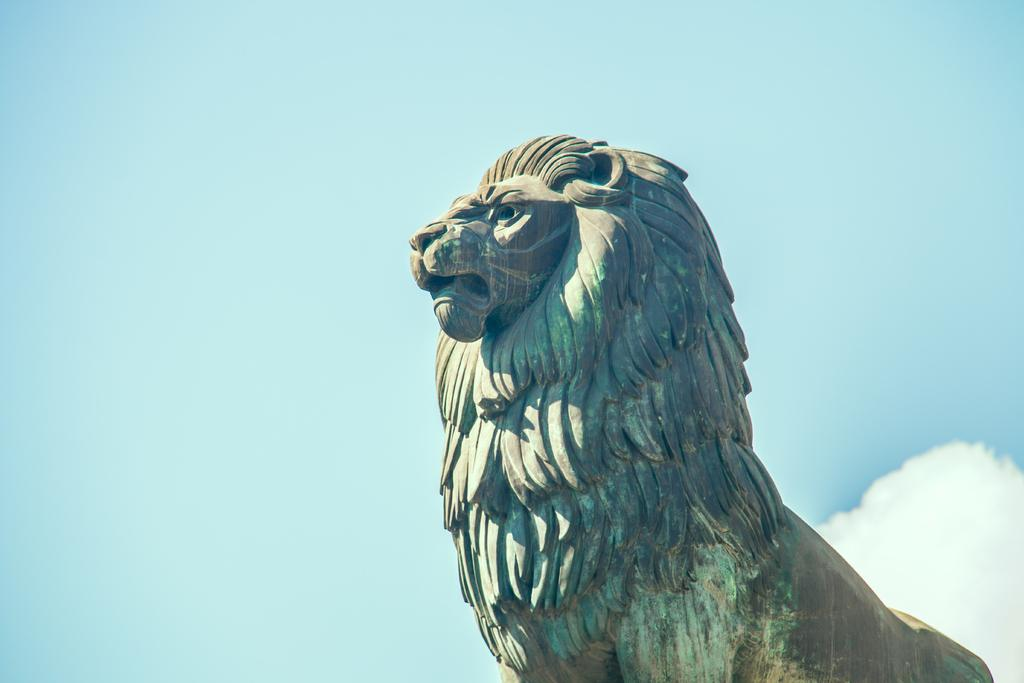What is the main subject of the picture? The main subject of the picture is a statue of a lion. What color is the statue? The statue is blue in color. What can be seen in the sky in the picture? The sky is clear in the picture. How many cups can be seen on the board in the image? There are no cups or boards present in the image; it features a blue statue of a lion and a clear sky. 